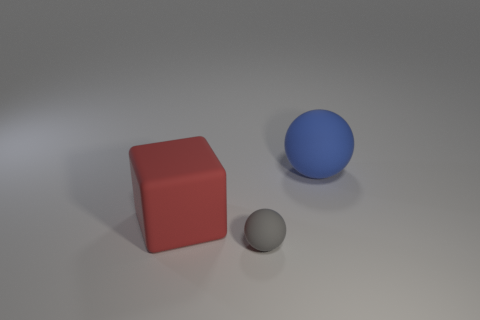Add 3 big purple balls. How many objects exist? 6 Subtract all cubes. How many objects are left? 2 Add 2 small gray rubber objects. How many small gray rubber objects exist? 3 Subtract 0 green cubes. How many objects are left? 3 Subtract all big green things. Subtract all red matte blocks. How many objects are left? 2 Add 2 matte objects. How many matte objects are left? 5 